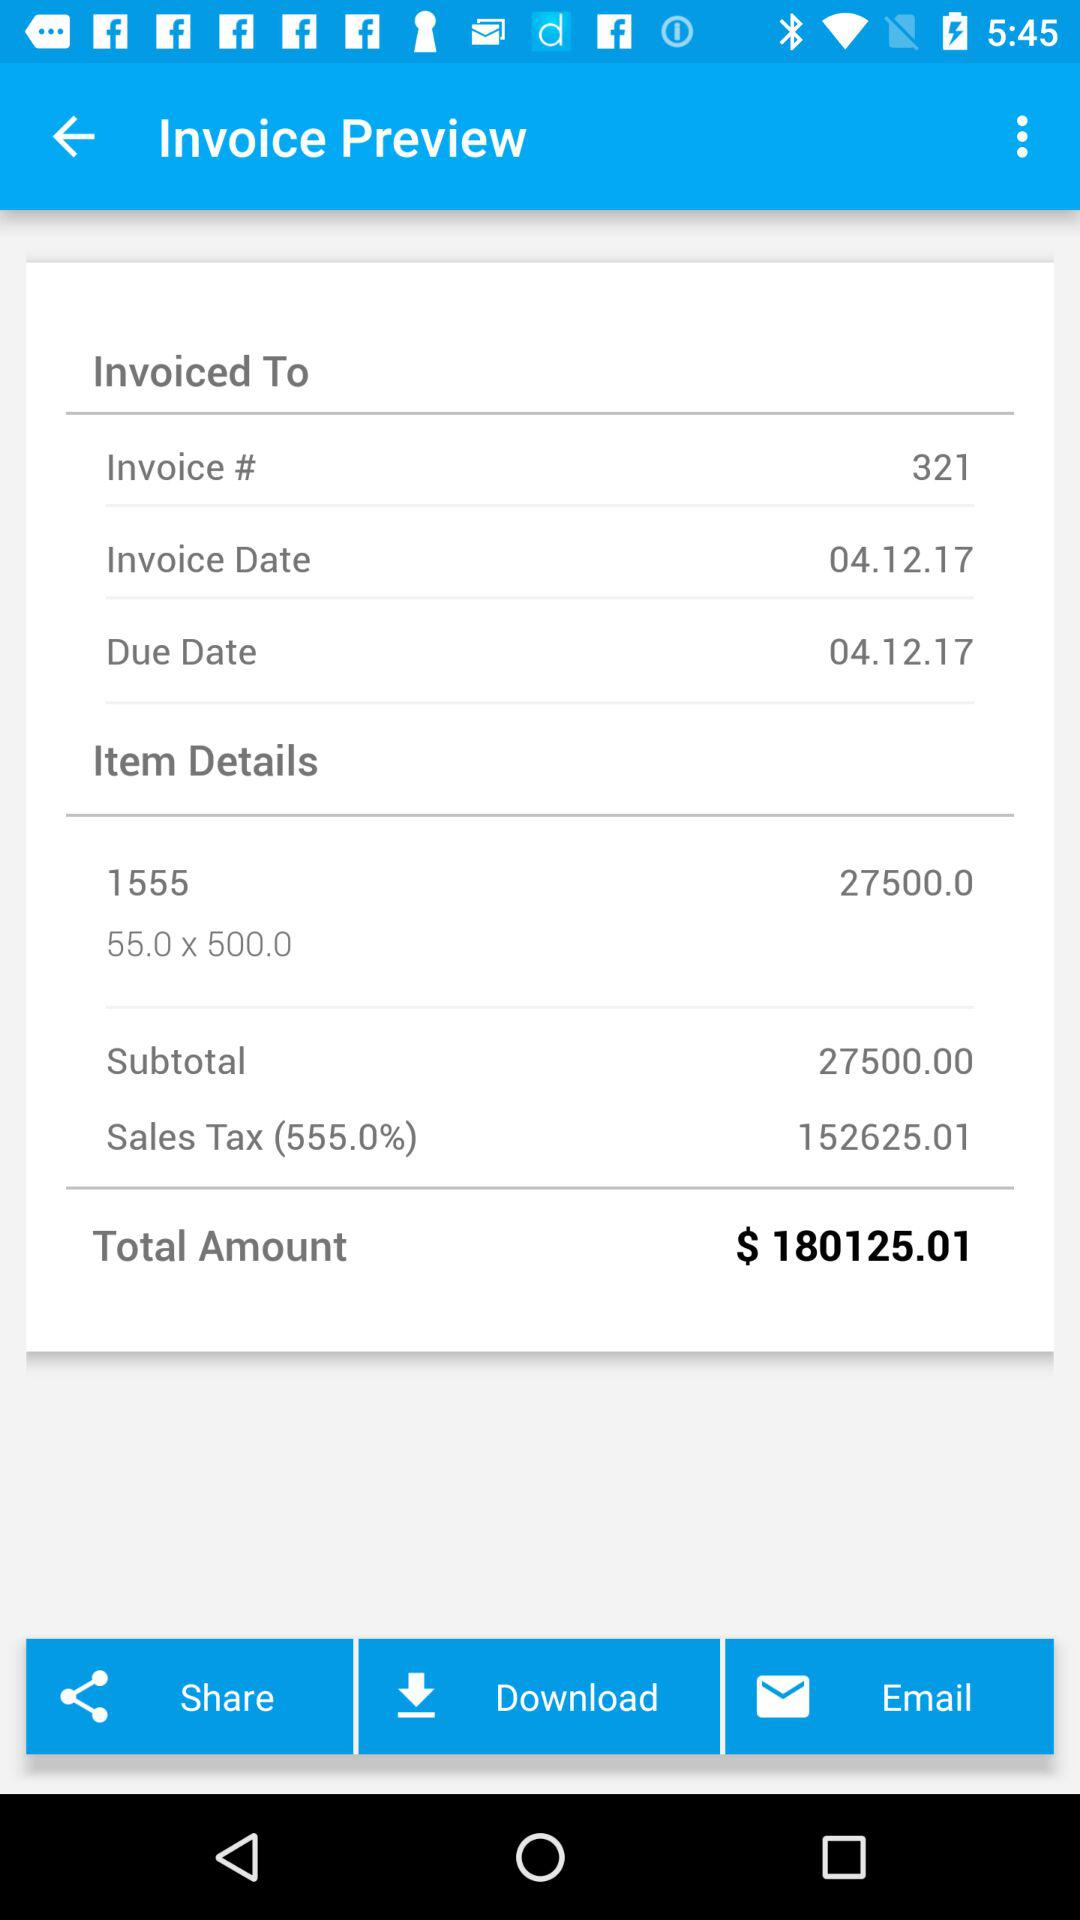What is the invoice number? The invoice number is 321. 